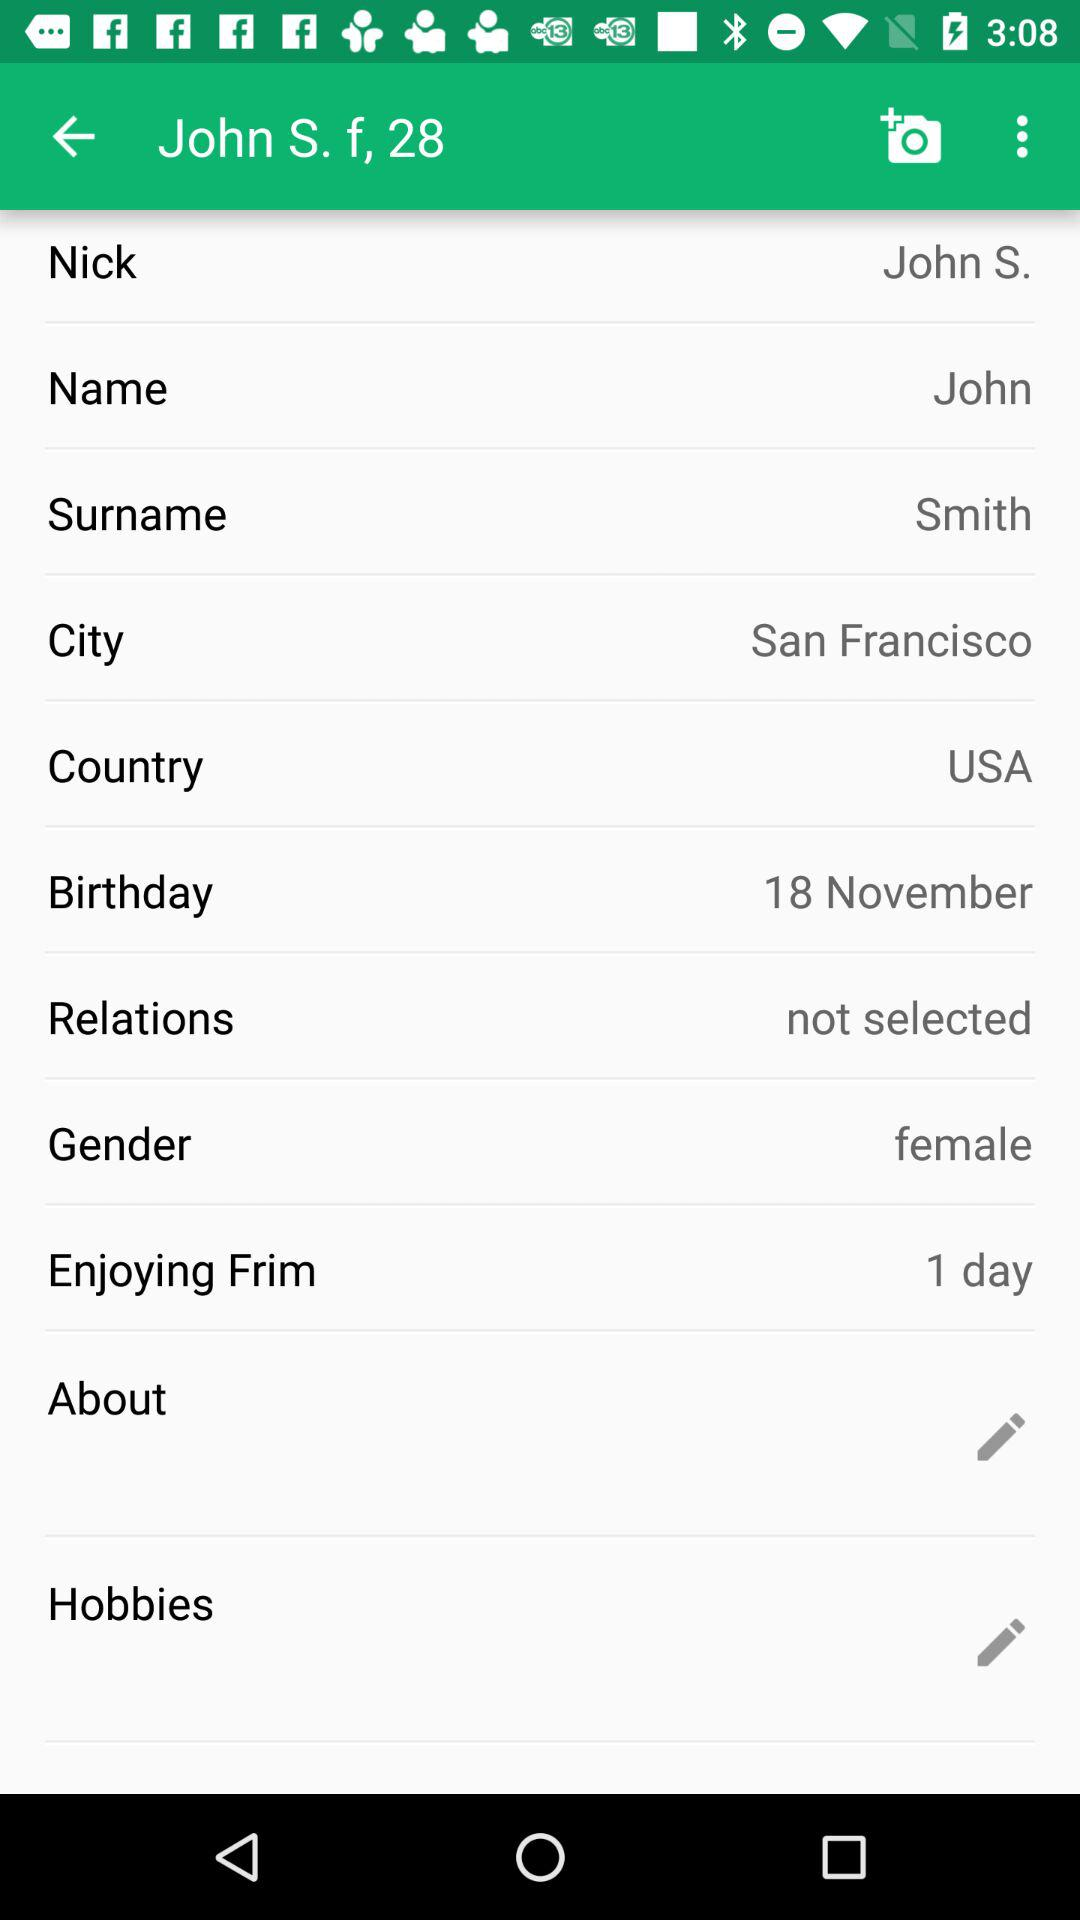What is the country name? The country name is the USA. 